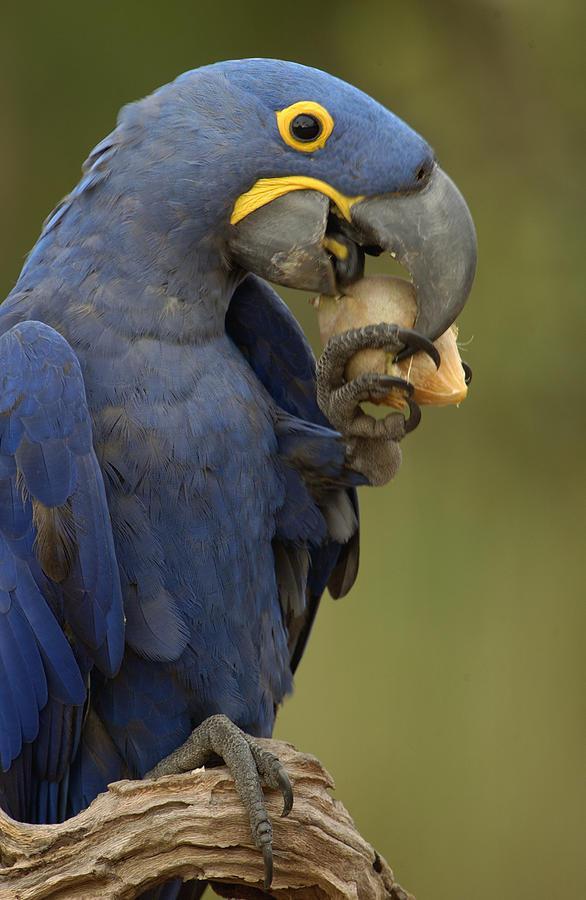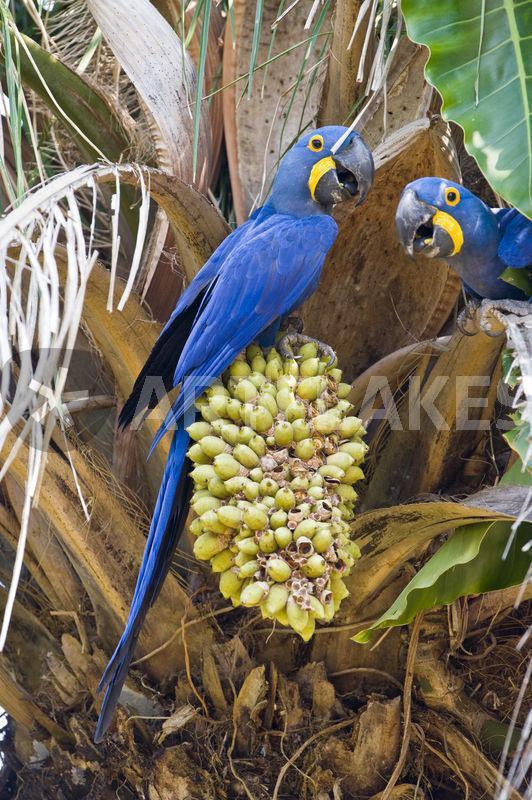The first image is the image on the left, the second image is the image on the right. Evaluate the accuracy of this statement regarding the images: "There are three parrots.". Is it true? Answer yes or no. Yes. The first image is the image on the left, the second image is the image on the right. For the images shown, is this caption "blue macaw are perched on a large pod in the tree" true? Answer yes or no. Yes. 